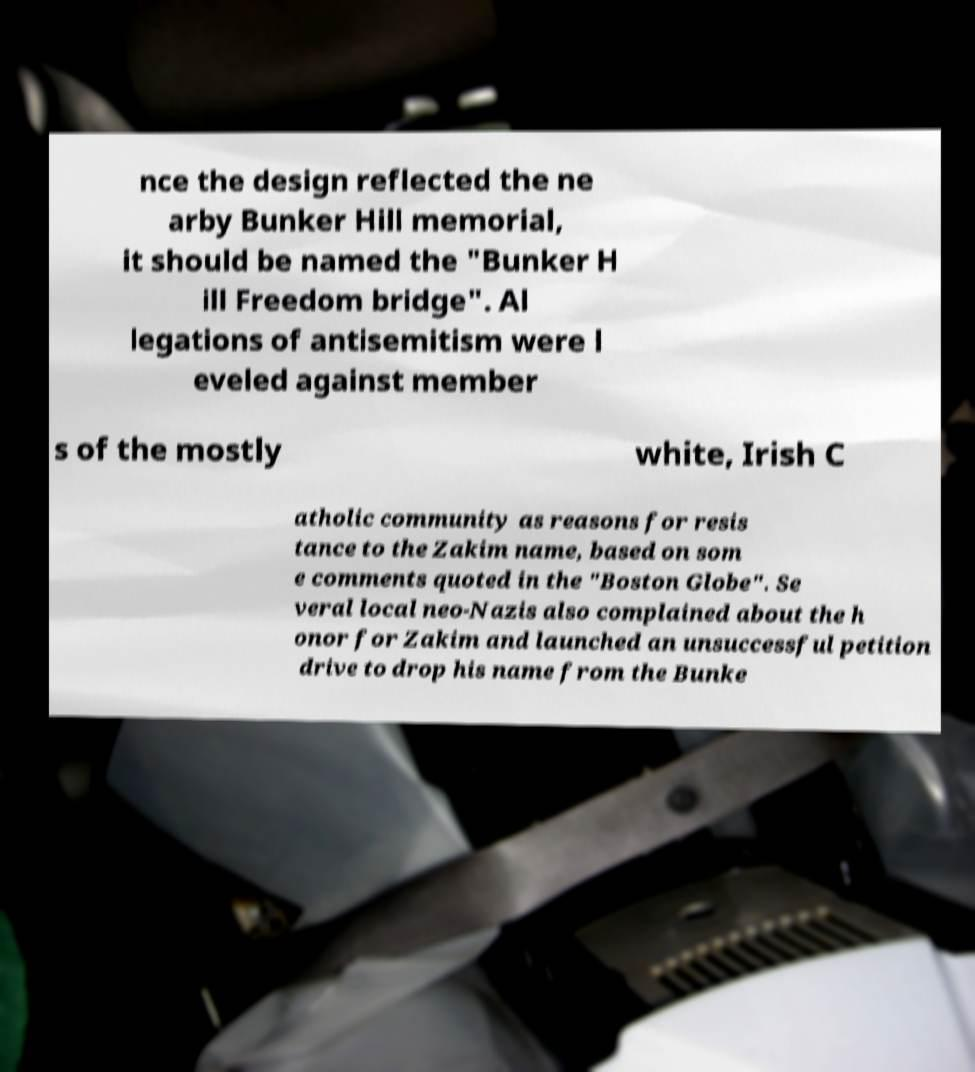What messages or text are displayed in this image? I need them in a readable, typed format. nce the design reflected the ne arby Bunker Hill memorial, it should be named the "Bunker H ill Freedom bridge". Al legations of antisemitism were l eveled against member s of the mostly white, Irish C atholic community as reasons for resis tance to the Zakim name, based on som e comments quoted in the "Boston Globe". Se veral local neo-Nazis also complained about the h onor for Zakim and launched an unsuccessful petition drive to drop his name from the Bunke 